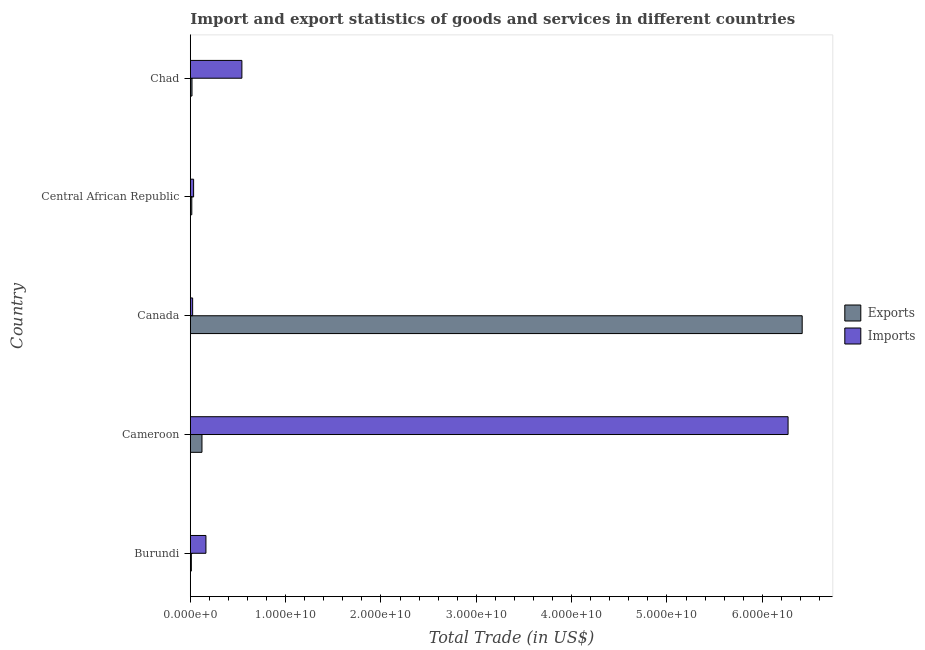How many different coloured bars are there?
Offer a very short reply. 2. Are the number of bars per tick equal to the number of legend labels?
Keep it short and to the point. Yes. What is the label of the 5th group of bars from the top?
Give a very brief answer. Burundi. What is the export of goods and services in Cameroon?
Provide a short and direct response. 1.22e+09. Across all countries, what is the maximum export of goods and services?
Your answer should be very brief. 6.42e+1. Across all countries, what is the minimum export of goods and services?
Keep it short and to the point. 1.11e+08. In which country was the imports of goods and services minimum?
Your answer should be very brief. Canada. What is the total export of goods and services in the graph?
Make the answer very short. 6.59e+1. What is the difference between the imports of goods and services in Cameroon and that in Canada?
Provide a short and direct response. 6.25e+1. What is the difference between the export of goods and services in Cameroon and the imports of goods and services in Central African Republic?
Your answer should be very brief. 8.77e+08. What is the average imports of goods and services per country?
Your response must be concise. 1.41e+1. What is the difference between the imports of goods and services and export of goods and services in Chad?
Make the answer very short. 5.23e+09. In how many countries, is the imports of goods and services greater than 26000000000 US$?
Your answer should be compact. 1. What is the ratio of the export of goods and services in Canada to that in Central African Republic?
Give a very brief answer. 408.32. Is the imports of goods and services in Canada less than that in Central African Republic?
Keep it short and to the point. Yes. What is the difference between the highest and the second highest export of goods and services?
Keep it short and to the point. 6.30e+1. What is the difference between the highest and the lowest imports of goods and services?
Keep it short and to the point. 6.25e+1. Is the sum of the export of goods and services in Burundi and Cameroon greater than the maximum imports of goods and services across all countries?
Keep it short and to the point. No. What does the 1st bar from the top in Burundi represents?
Provide a succinct answer. Imports. What does the 1st bar from the bottom in Central African Republic represents?
Make the answer very short. Exports. How many bars are there?
Offer a terse response. 10. Are all the bars in the graph horizontal?
Offer a terse response. Yes. Are the values on the major ticks of X-axis written in scientific E-notation?
Ensure brevity in your answer.  Yes. Does the graph contain any zero values?
Offer a very short reply. No. How many legend labels are there?
Your answer should be very brief. 2. How are the legend labels stacked?
Your answer should be compact. Vertical. What is the title of the graph?
Ensure brevity in your answer.  Import and export statistics of goods and services in different countries. Does "Age 65(male)" appear as one of the legend labels in the graph?
Give a very brief answer. No. What is the label or title of the X-axis?
Your response must be concise. Total Trade (in US$). What is the label or title of the Y-axis?
Offer a very short reply. Country. What is the Total Trade (in US$) in Exports in Burundi?
Make the answer very short. 1.11e+08. What is the Total Trade (in US$) in Imports in Burundi?
Your response must be concise. 1.64e+09. What is the Total Trade (in US$) in Exports in Cameroon?
Offer a terse response. 1.22e+09. What is the Total Trade (in US$) in Imports in Cameroon?
Provide a succinct answer. 6.27e+1. What is the Total Trade (in US$) in Exports in Canada?
Give a very brief answer. 6.42e+1. What is the Total Trade (in US$) in Imports in Canada?
Provide a succinct answer. 2.46e+08. What is the Total Trade (in US$) of Exports in Central African Republic?
Provide a short and direct response. 1.57e+08. What is the Total Trade (in US$) in Imports in Central African Republic?
Provide a succinct answer. 3.48e+08. What is the Total Trade (in US$) in Exports in Chad?
Your response must be concise. 1.79e+08. What is the Total Trade (in US$) of Imports in Chad?
Provide a succinct answer. 5.41e+09. Across all countries, what is the maximum Total Trade (in US$) of Exports?
Your answer should be compact. 6.42e+1. Across all countries, what is the maximum Total Trade (in US$) in Imports?
Provide a succinct answer. 6.27e+1. Across all countries, what is the minimum Total Trade (in US$) of Exports?
Keep it short and to the point. 1.11e+08. Across all countries, what is the minimum Total Trade (in US$) in Imports?
Your response must be concise. 2.46e+08. What is the total Total Trade (in US$) in Exports in the graph?
Offer a terse response. 6.59e+1. What is the total Total Trade (in US$) in Imports in the graph?
Provide a succinct answer. 7.04e+1. What is the difference between the Total Trade (in US$) in Exports in Burundi and that in Cameroon?
Give a very brief answer. -1.11e+09. What is the difference between the Total Trade (in US$) in Imports in Burundi and that in Cameroon?
Provide a succinct answer. -6.11e+1. What is the difference between the Total Trade (in US$) in Exports in Burundi and that in Canada?
Your answer should be compact. -6.41e+1. What is the difference between the Total Trade (in US$) of Imports in Burundi and that in Canada?
Give a very brief answer. 1.40e+09. What is the difference between the Total Trade (in US$) in Exports in Burundi and that in Central African Republic?
Provide a short and direct response. -4.64e+07. What is the difference between the Total Trade (in US$) in Imports in Burundi and that in Central African Republic?
Give a very brief answer. 1.29e+09. What is the difference between the Total Trade (in US$) of Exports in Burundi and that in Chad?
Offer a very short reply. -6.77e+07. What is the difference between the Total Trade (in US$) in Imports in Burundi and that in Chad?
Keep it short and to the point. -3.77e+09. What is the difference between the Total Trade (in US$) in Exports in Cameroon and that in Canada?
Your answer should be very brief. -6.30e+1. What is the difference between the Total Trade (in US$) of Imports in Cameroon and that in Canada?
Offer a terse response. 6.25e+1. What is the difference between the Total Trade (in US$) in Exports in Cameroon and that in Central African Republic?
Make the answer very short. 1.07e+09. What is the difference between the Total Trade (in US$) of Imports in Cameroon and that in Central African Republic?
Provide a succinct answer. 6.24e+1. What is the difference between the Total Trade (in US$) in Exports in Cameroon and that in Chad?
Keep it short and to the point. 1.05e+09. What is the difference between the Total Trade (in US$) of Imports in Cameroon and that in Chad?
Provide a short and direct response. 5.73e+1. What is the difference between the Total Trade (in US$) of Exports in Canada and that in Central African Republic?
Ensure brevity in your answer.  6.40e+1. What is the difference between the Total Trade (in US$) in Imports in Canada and that in Central African Republic?
Your answer should be very brief. -1.02e+08. What is the difference between the Total Trade (in US$) in Exports in Canada and that in Chad?
Give a very brief answer. 6.40e+1. What is the difference between the Total Trade (in US$) in Imports in Canada and that in Chad?
Ensure brevity in your answer.  -5.17e+09. What is the difference between the Total Trade (in US$) of Exports in Central African Republic and that in Chad?
Offer a terse response. -2.14e+07. What is the difference between the Total Trade (in US$) of Imports in Central African Republic and that in Chad?
Make the answer very short. -5.06e+09. What is the difference between the Total Trade (in US$) of Exports in Burundi and the Total Trade (in US$) of Imports in Cameroon?
Provide a short and direct response. -6.26e+1. What is the difference between the Total Trade (in US$) of Exports in Burundi and the Total Trade (in US$) of Imports in Canada?
Your response must be concise. -1.35e+08. What is the difference between the Total Trade (in US$) of Exports in Burundi and the Total Trade (in US$) of Imports in Central African Republic?
Give a very brief answer. -2.37e+08. What is the difference between the Total Trade (in US$) in Exports in Burundi and the Total Trade (in US$) in Imports in Chad?
Provide a short and direct response. -5.30e+09. What is the difference between the Total Trade (in US$) of Exports in Cameroon and the Total Trade (in US$) of Imports in Canada?
Ensure brevity in your answer.  9.79e+08. What is the difference between the Total Trade (in US$) in Exports in Cameroon and the Total Trade (in US$) in Imports in Central African Republic?
Give a very brief answer. 8.77e+08. What is the difference between the Total Trade (in US$) of Exports in Cameroon and the Total Trade (in US$) of Imports in Chad?
Your answer should be compact. -4.19e+09. What is the difference between the Total Trade (in US$) in Exports in Canada and the Total Trade (in US$) in Imports in Central African Republic?
Your answer should be compact. 6.38e+1. What is the difference between the Total Trade (in US$) in Exports in Canada and the Total Trade (in US$) in Imports in Chad?
Ensure brevity in your answer.  5.88e+1. What is the difference between the Total Trade (in US$) in Exports in Central African Republic and the Total Trade (in US$) in Imports in Chad?
Ensure brevity in your answer.  -5.25e+09. What is the average Total Trade (in US$) of Exports per country?
Provide a short and direct response. 1.32e+1. What is the average Total Trade (in US$) in Imports per country?
Provide a short and direct response. 1.41e+1. What is the difference between the Total Trade (in US$) of Exports and Total Trade (in US$) of Imports in Burundi?
Ensure brevity in your answer.  -1.53e+09. What is the difference between the Total Trade (in US$) of Exports and Total Trade (in US$) of Imports in Cameroon?
Offer a terse response. -6.15e+1. What is the difference between the Total Trade (in US$) in Exports and Total Trade (in US$) in Imports in Canada?
Your answer should be compact. 6.39e+1. What is the difference between the Total Trade (in US$) in Exports and Total Trade (in US$) in Imports in Central African Republic?
Your response must be concise. -1.91e+08. What is the difference between the Total Trade (in US$) of Exports and Total Trade (in US$) of Imports in Chad?
Your answer should be compact. -5.23e+09. What is the ratio of the Total Trade (in US$) in Exports in Burundi to that in Cameroon?
Give a very brief answer. 0.09. What is the ratio of the Total Trade (in US$) of Imports in Burundi to that in Cameroon?
Give a very brief answer. 0.03. What is the ratio of the Total Trade (in US$) of Exports in Burundi to that in Canada?
Keep it short and to the point. 0. What is the ratio of the Total Trade (in US$) in Imports in Burundi to that in Canada?
Make the answer very short. 6.67. What is the ratio of the Total Trade (in US$) in Exports in Burundi to that in Central African Republic?
Keep it short and to the point. 0.7. What is the ratio of the Total Trade (in US$) of Imports in Burundi to that in Central African Republic?
Offer a very short reply. 4.72. What is the ratio of the Total Trade (in US$) in Exports in Burundi to that in Chad?
Provide a short and direct response. 0.62. What is the ratio of the Total Trade (in US$) of Imports in Burundi to that in Chad?
Your answer should be compact. 0.3. What is the ratio of the Total Trade (in US$) in Exports in Cameroon to that in Canada?
Your answer should be very brief. 0.02. What is the ratio of the Total Trade (in US$) in Imports in Cameroon to that in Canada?
Keep it short and to the point. 254.7. What is the ratio of the Total Trade (in US$) of Exports in Cameroon to that in Central African Republic?
Ensure brevity in your answer.  7.79. What is the ratio of the Total Trade (in US$) of Imports in Cameroon to that in Central African Republic?
Your answer should be very brief. 180.26. What is the ratio of the Total Trade (in US$) of Exports in Cameroon to that in Chad?
Your response must be concise. 6.86. What is the ratio of the Total Trade (in US$) of Imports in Cameroon to that in Chad?
Keep it short and to the point. 11.59. What is the ratio of the Total Trade (in US$) of Exports in Canada to that in Central African Republic?
Keep it short and to the point. 408.32. What is the ratio of the Total Trade (in US$) in Imports in Canada to that in Central African Republic?
Keep it short and to the point. 0.71. What is the ratio of the Total Trade (in US$) in Exports in Canada to that in Chad?
Give a very brief answer. 359.49. What is the ratio of the Total Trade (in US$) in Imports in Canada to that in Chad?
Your answer should be compact. 0.05. What is the ratio of the Total Trade (in US$) in Exports in Central African Republic to that in Chad?
Provide a succinct answer. 0.88. What is the ratio of the Total Trade (in US$) in Imports in Central African Republic to that in Chad?
Give a very brief answer. 0.06. What is the difference between the highest and the second highest Total Trade (in US$) in Exports?
Keep it short and to the point. 6.30e+1. What is the difference between the highest and the second highest Total Trade (in US$) in Imports?
Provide a short and direct response. 5.73e+1. What is the difference between the highest and the lowest Total Trade (in US$) of Exports?
Provide a short and direct response. 6.41e+1. What is the difference between the highest and the lowest Total Trade (in US$) of Imports?
Make the answer very short. 6.25e+1. 